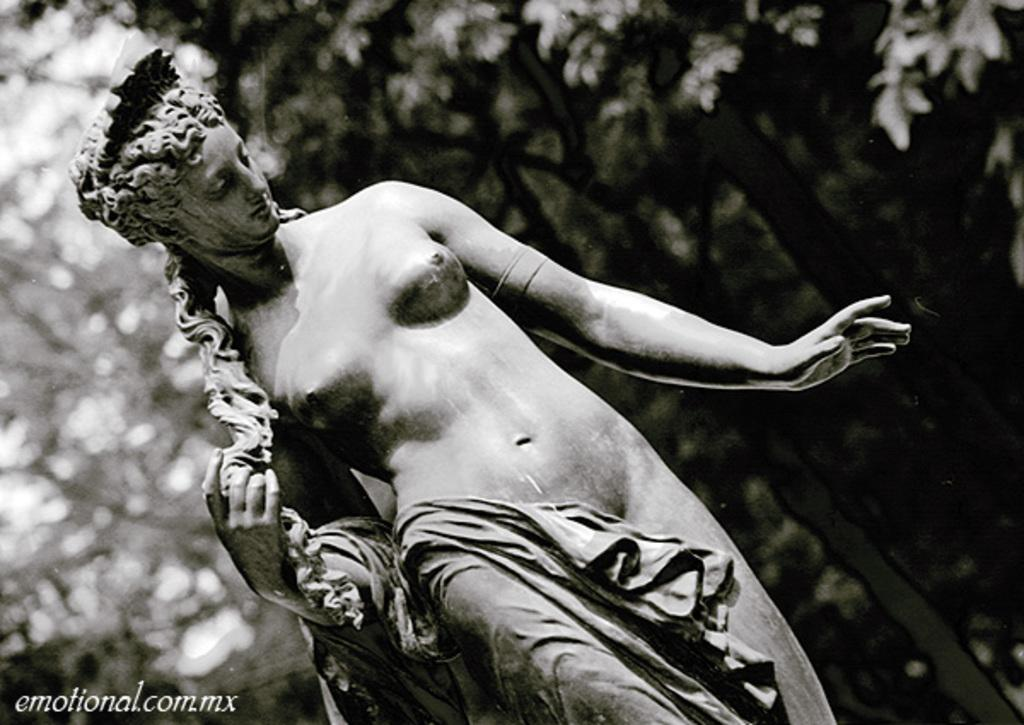What is the main subject in the center of the image? There is a statue in the center of the image. What can be seen in the background of the image? There are trees in the background of the image. What type of coal is being used for the treatment of the stranger in the image? There is no coal, stranger, or treatment present in the image. 